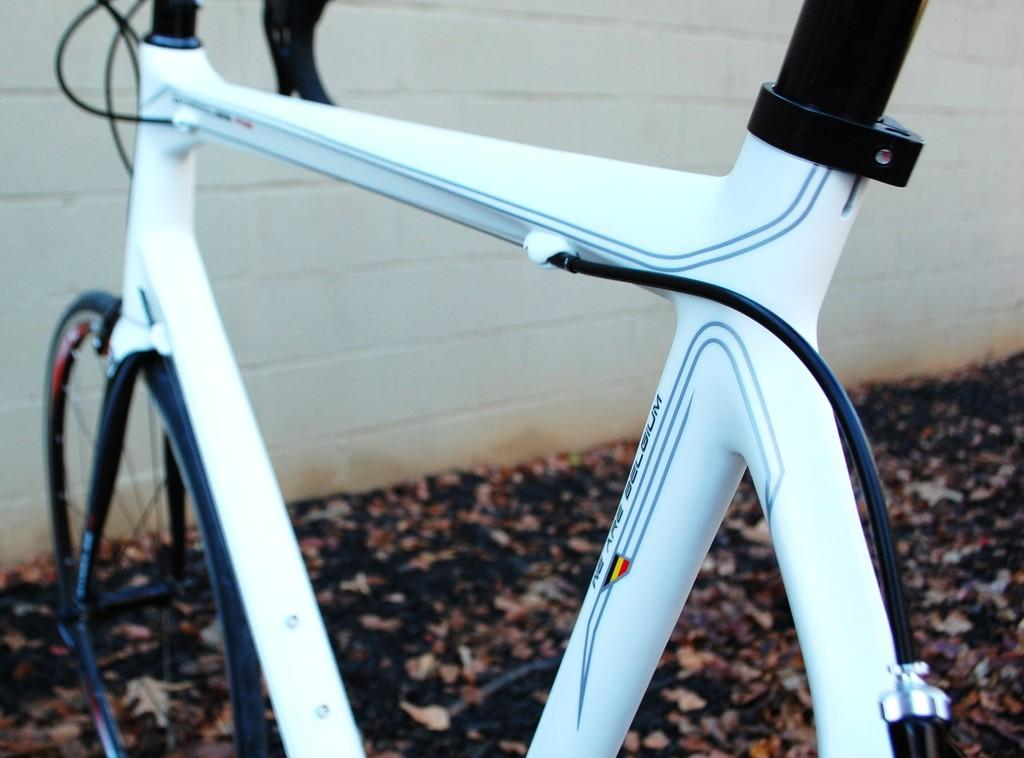What is the main object in the image? There is a bicycle in the image. What can be seen on the ground in the image? There are leaves on the ground in the image. What type of structure is visible in the image? There is a wall in the image. Where is the sister standing in the image? There is no sister present in the image. What type of pest can be seen crawling on the wall in the image? There are no pests visible in the image; only the bicycle, leaves, and wall are present. 